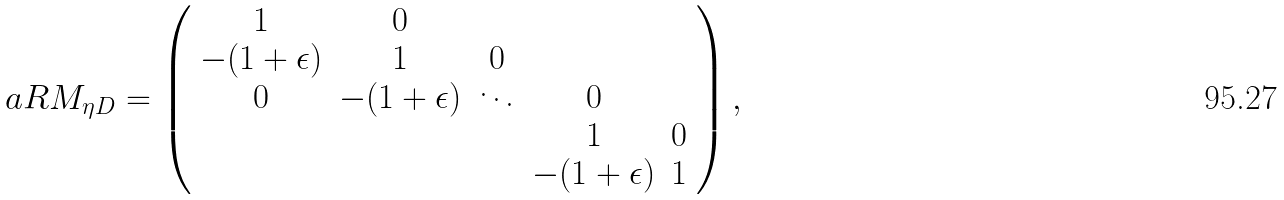<formula> <loc_0><loc_0><loc_500><loc_500>a R M _ { \eta D } = \left ( \begin{array} { c c c c c } 1 & 0 \\ - ( 1 + \epsilon ) & 1 & 0 \\ 0 & - ( 1 + \epsilon ) & \ddots & 0 \\ & & & 1 & 0 \\ & & & - ( 1 + \epsilon ) & 1 \end{array} \right ) ,</formula> 